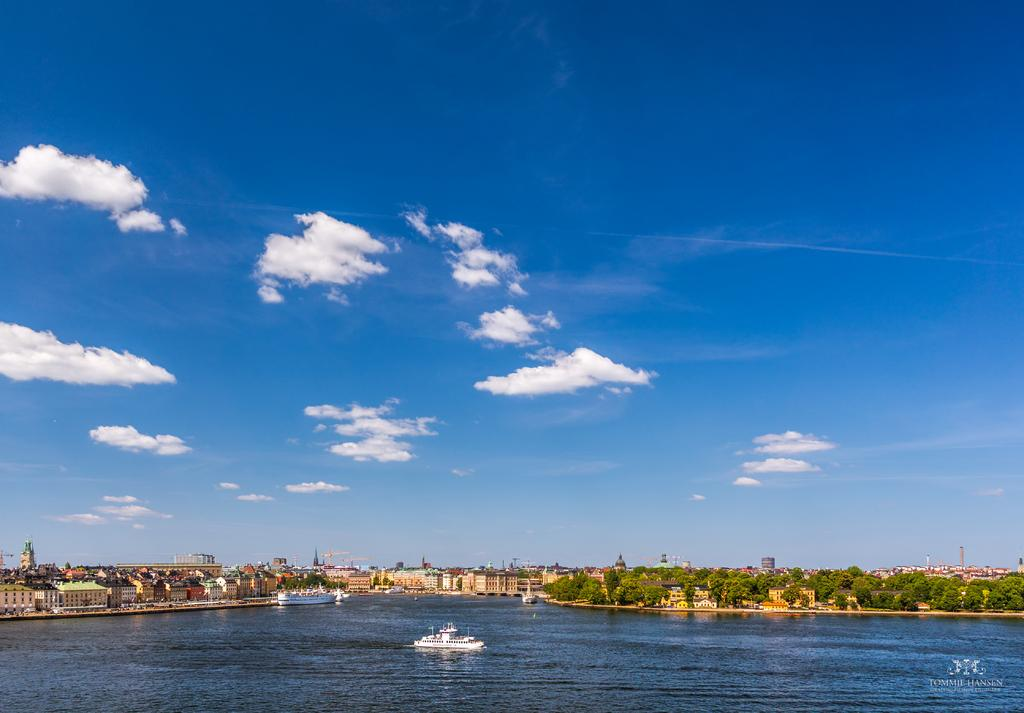What is happening in the water in the image? There are ships sailing on the water in the image. What type of structures can be seen in the image? There are buildings visible in the image. What type of vegetation is present in the image? There are trees in the image. What type of objects are present in the image? There are poles in the image. What is visible above the water and structures in the image? The sky is visible in the image. What can be seen in the sky in the image? Clouds are present in the sky. What color is the coat worn by the wrist in the image? There is no wrist or coat present in the image. What type of channel can be seen in the image? There is no channel present in the image. 